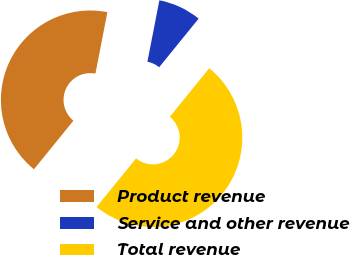Convert chart. <chart><loc_0><loc_0><loc_500><loc_500><pie_chart><fcel>Product revenue<fcel>Service and other revenue<fcel>Total revenue<nl><fcel>42.21%<fcel>7.79%<fcel>50.0%<nl></chart> 